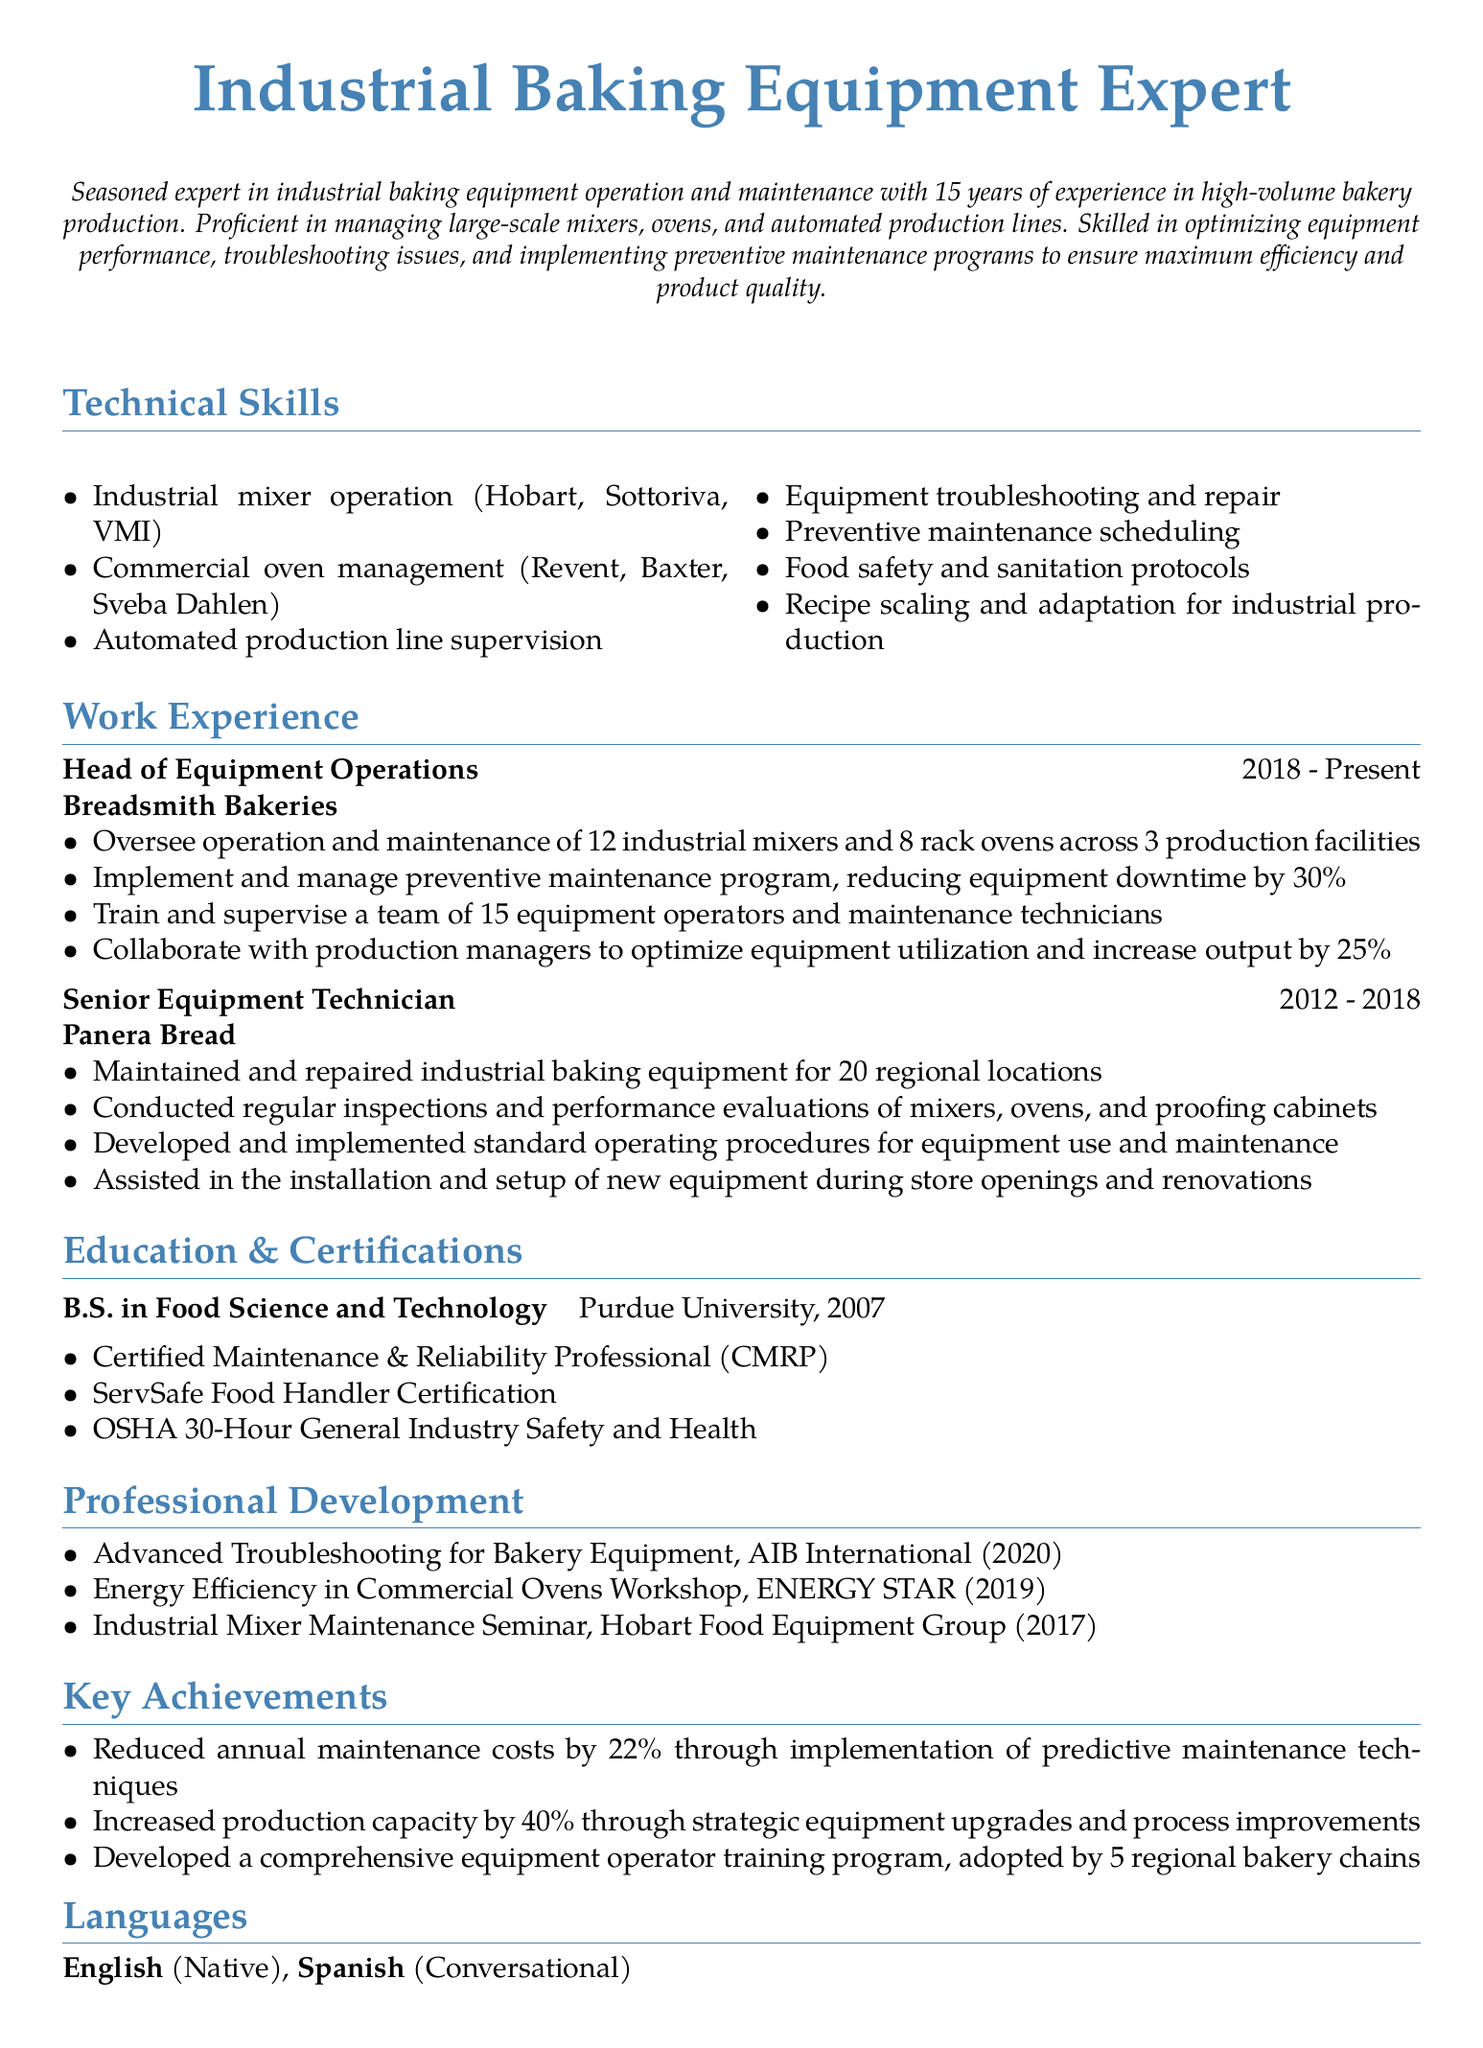What is the individual's current position? The document states their current job title is Head of Equipment Operations.
Answer: Head of Equipment Operations How many years of experience does the individual have? The personal summary mentions they have 15 years of experience in industrial baking equipment.
Answer: 15 years Which company did the individual work for from 2012 to 2018? The document lists Panera Bread as the employer during that time frame.
Answer: Panera Bread What percentage did the individual reduce equipment downtime by? The responsibilities indicate a reduction in equipment downtime by 30%.
Answer: 30% What type of degree does the individual hold? The education section specifies a Bachelor of Science in Food Science and Technology.
Answer: Bachelor of Science in Food Science and Technology What certification indicates expertise in maintenance and reliability? The document includes the Certified Maintenance & Reliability Professional as one of their qualifications.
Answer: Certified Maintenance & Reliability Professional How many people did the individual train and supervise at Breadsmith Bakeries? The work experience mentions they trained and supervised a team of 15 equipment operators and maintenance technicians.
Answer: 15 Which workshop focused on energy efficiency for commercial ovens? The professional development section lists the Energy Efficiency in Commercial Ovens Workshop as a relevant workshop attended.
Answer: Energy Efficiency in Commercial Ovens Workshop What was one significant achievement related to production capacity? The key achievements section reveals the individual increased production capacity by 40%.
Answer: 40% 